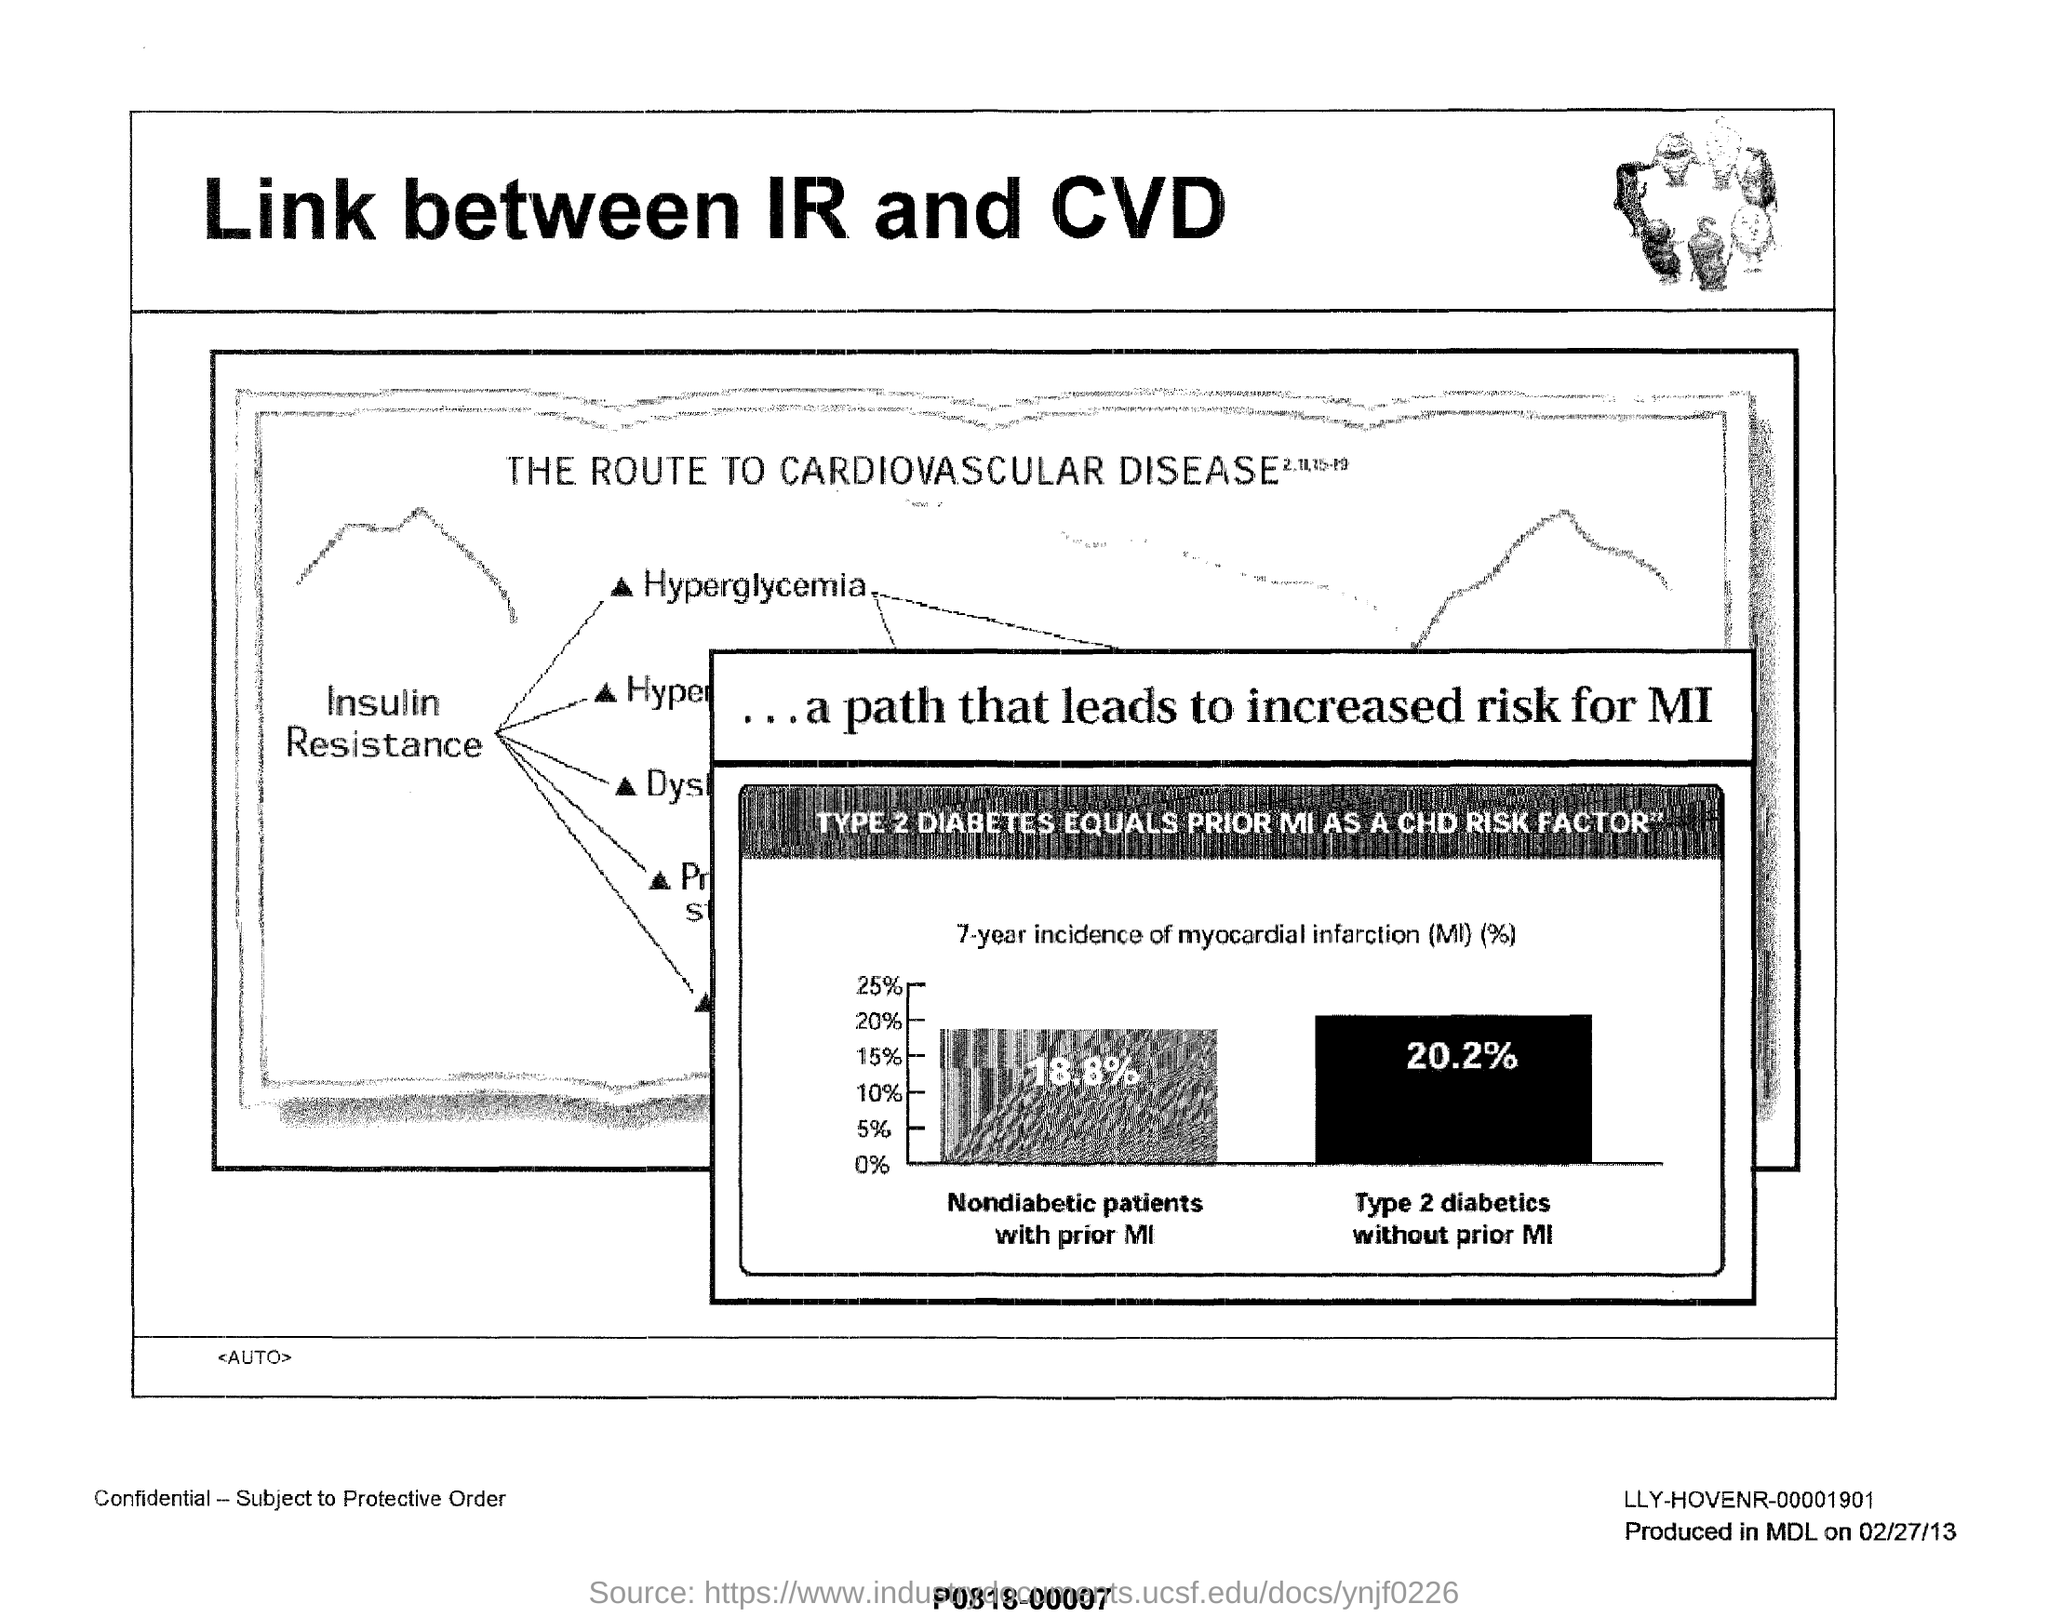Draw attention to some important aspects in this diagram. In this study, the percentage of nondiabetic patients with prior myocardial infarction was found to be 18.8%. This document explores the link between Induced Rivaroxaban Deficiency and Cardiovascular Disease. 